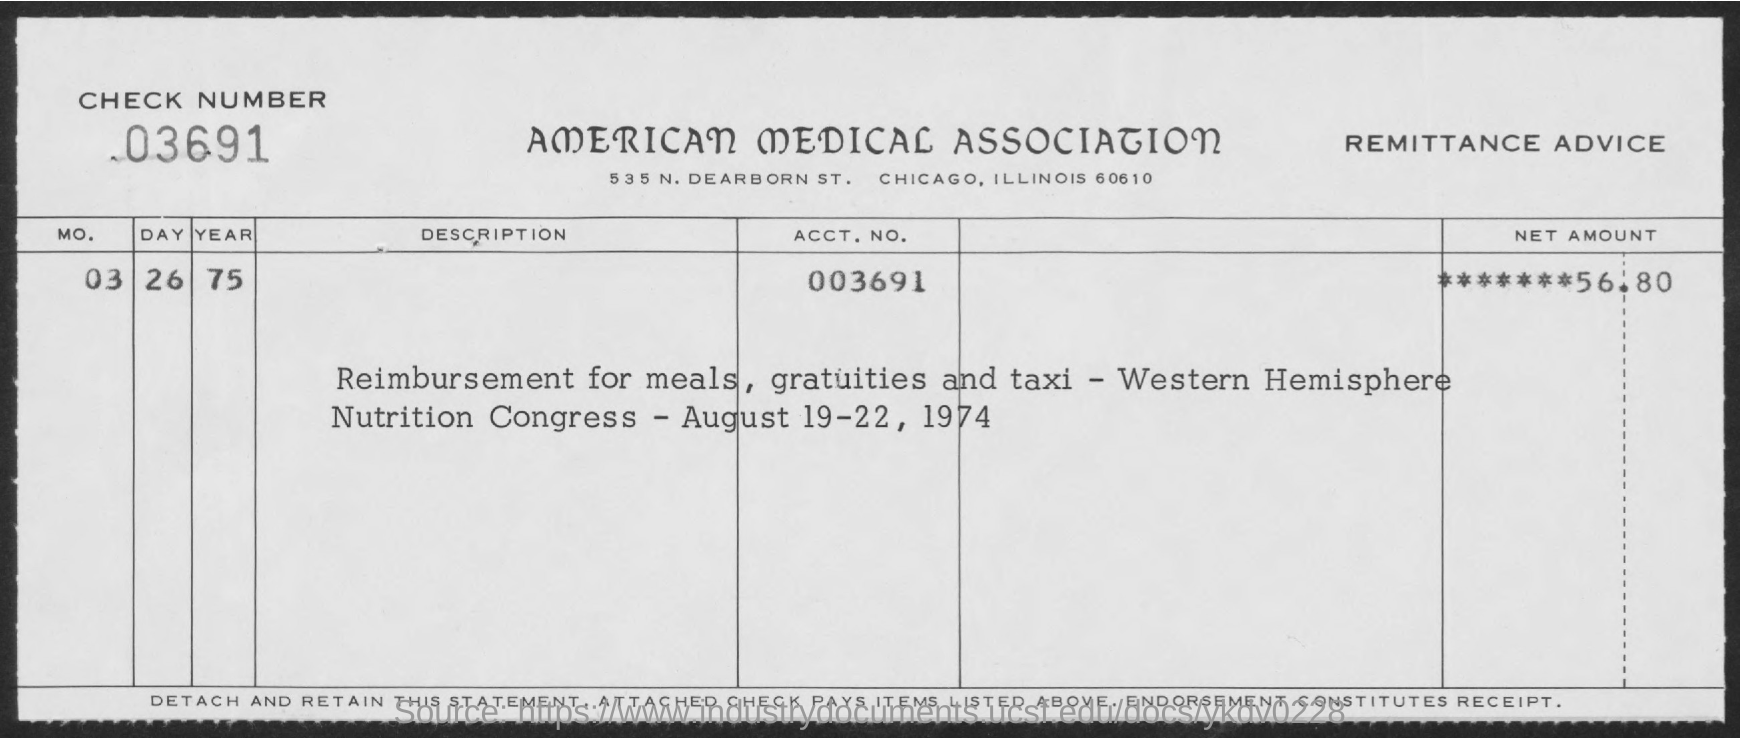What is the Check Number ?
Provide a succinct answer. 03691. What is the title of the document ?
Give a very brief answer. AMERICAn MEDICAL ASSOCIATIOn. What is the ACCt.NO?
Give a very brief answer. 003691. 